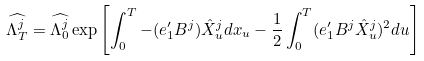Convert formula to latex. <formula><loc_0><loc_0><loc_500><loc_500>\widehat { \Lambda ^ { j } _ { T } } = \widehat { \Lambda ^ { j } _ { 0 } } \exp \left [ \int _ { 0 } ^ { T } - ( e _ { 1 } ^ { \prime } B ^ { j } ) \hat { X } ^ { j } _ { u } d x _ { u } - \frac { 1 } { 2 } \int _ { 0 } ^ { T } ( e _ { 1 } ^ { \prime } B ^ { j } \hat { X } ^ { j } _ { u } ) ^ { 2 } d u \right ]</formula> 